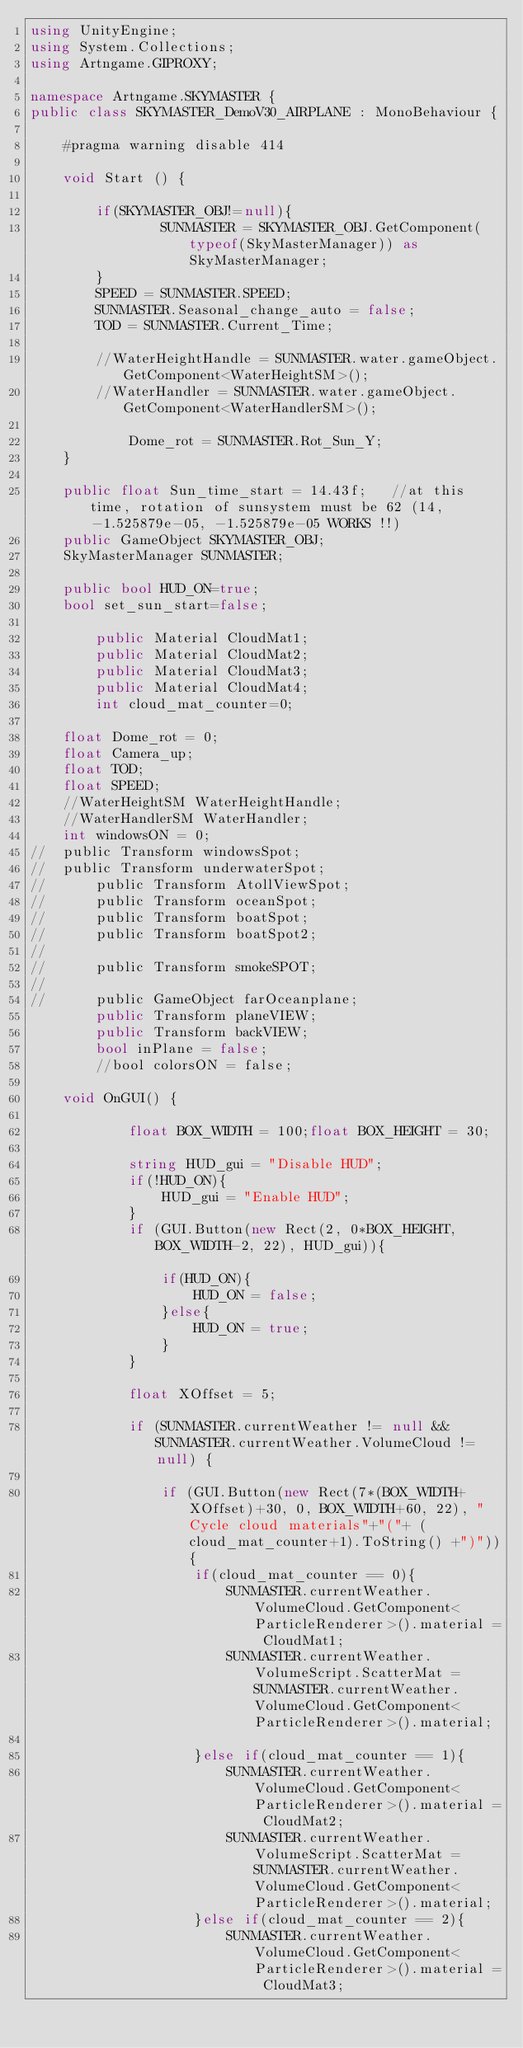<code> <loc_0><loc_0><loc_500><loc_500><_C#_>using UnityEngine;
using System.Collections;
using Artngame.GIPROXY;

namespace Artngame.SKYMASTER {
public class SKYMASTER_DemoV30_AIRPLANE : MonoBehaviour {

	#pragma warning disable 414

	void Start () {

		if(SKYMASTER_OBJ!=null){
				SUNMASTER = SKYMASTER_OBJ.GetComponent(typeof(SkyMasterManager)) as SkyMasterManager;
		}
		SPEED = SUNMASTER.SPEED;
		SUNMASTER.Seasonal_change_auto = false;
		TOD = SUNMASTER.Current_Time;

		//WaterHeightHandle = SUNMASTER.water.gameObject.GetComponent<WaterHeightSM>();
		//WaterHandler = SUNMASTER.water.gameObject.GetComponent<WaterHandlerSM>();

			Dome_rot = SUNMASTER.Rot_Sun_Y;
	}

	public float Sun_time_start = 14.43f;	//at this time, rotation of sunsystem must be 62 (14, -1.525879e-05, -1.525879e-05 WORKS !!)
	public GameObject SKYMASTER_OBJ;
	SkyMasterManager SUNMASTER;
	
	public bool HUD_ON=true;
	bool set_sun_start=false;

		public Material CloudMat1;
		public Material CloudMat2;
		public Material CloudMat3;
		public Material CloudMat4;
		int cloud_mat_counter=0;

	float Dome_rot = 0;
	float Camera_up;
	float TOD;
	float SPEED;
	//WaterHeightSM WaterHeightHandle;
	//WaterHandlerSM WaterHandler;
	int windowsON = 0;
//	public Transform windowsSpot;
//	public Transform underwaterSpot;
//		public Transform AtollViewSpot;
//		public Transform oceanSpot;
//		public Transform boatSpot;
//		public Transform boatSpot2;
//
//		public Transform smokeSPOT;
//
//		public GameObject farOceanplane;
		public Transform planeVIEW;
		public Transform backVIEW;
		bool inPlane = false;
		//bool colorsON = false;

	void OnGUI() {

			float BOX_WIDTH = 100;float BOX_HEIGHT = 30;

			string HUD_gui = "Disable HUD";
			if(!HUD_ON){
				HUD_gui = "Enable HUD";
			}
			if (GUI.Button(new Rect(2, 0*BOX_HEIGHT, BOX_WIDTH-2, 22), HUD_gui)){				
				if(HUD_ON){
					HUD_ON = false;
				}else{
					HUD_ON = true;
				}				
			}

			float XOffset = 5;

			if (SUNMASTER.currentWeather != null && SUNMASTER.currentWeather.VolumeCloud != null) {

				if (GUI.Button(new Rect(7*(BOX_WIDTH+XOffset)+30, 0, BOX_WIDTH+60, 22), "Cycle cloud materials"+"("+ (cloud_mat_counter+1).ToString() +")")){
					if(cloud_mat_counter == 0){
						SUNMASTER.currentWeather.VolumeCloud.GetComponent<ParticleRenderer>().material = CloudMat1;
						SUNMASTER.currentWeather.VolumeScript.ScatterMat = SUNMASTER.currentWeather.VolumeCloud.GetComponent<ParticleRenderer>().material;

					}else if(cloud_mat_counter == 1){
						SUNMASTER.currentWeather.VolumeCloud.GetComponent<ParticleRenderer>().material = CloudMat2;
						SUNMASTER.currentWeather.VolumeScript.ScatterMat = SUNMASTER.currentWeather.VolumeCloud.GetComponent<ParticleRenderer>().material;
					}else if(cloud_mat_counter == 2){
						SUNMASTER.currentWeather.VolumeCloud.GetComponent<ParticleRenderer>().material = CloudMat3;</code> 